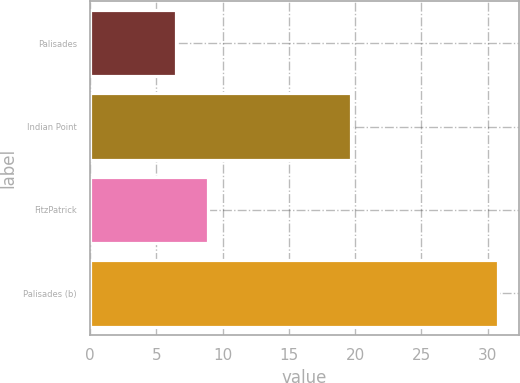Convert chart to OTSL. <chart><loc_0><loc_0><loc_500><loc_500><bar_chart><fcel>Palisades<fcel>Indian Point<fcel>FitzPatrick<fcel>Palisades (b)<nl><fcel>6.5<fcel>19.7<fcel>8.93<fcel>30.8<nl></chart> 